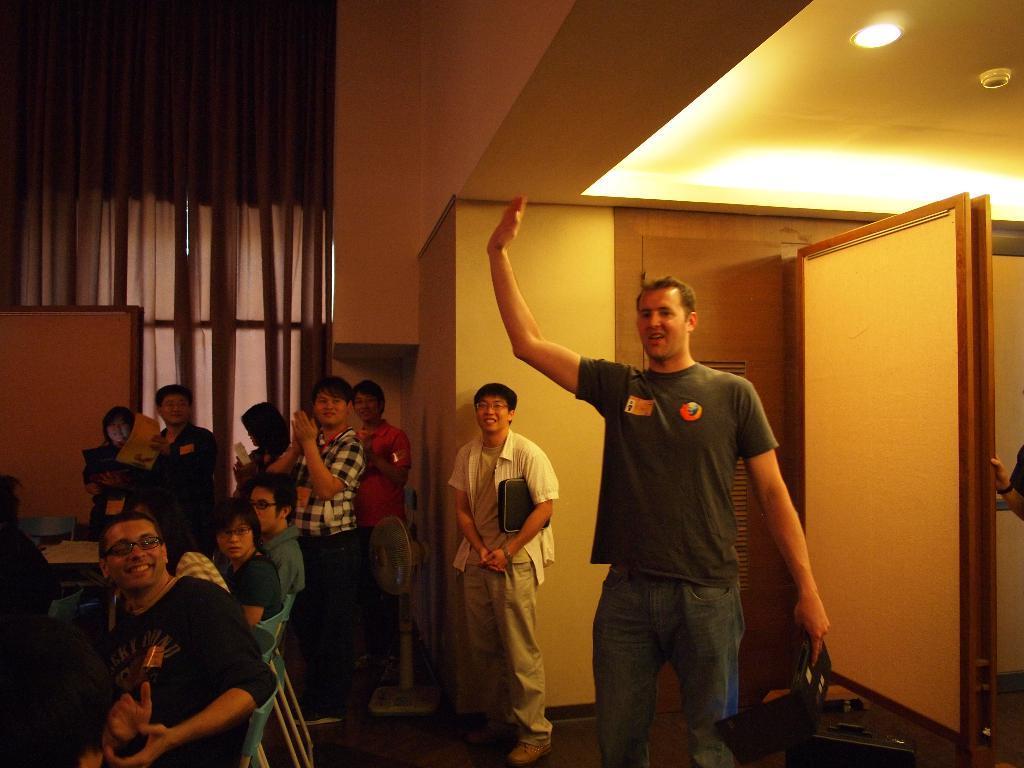In one or two sentences, can you explain what this image depicts? There is a group of people present as we can see at the bottom of this image. We can see a wall in the background. There is a door on the right side of this image. We can see curtains in the top left corner of this image. 